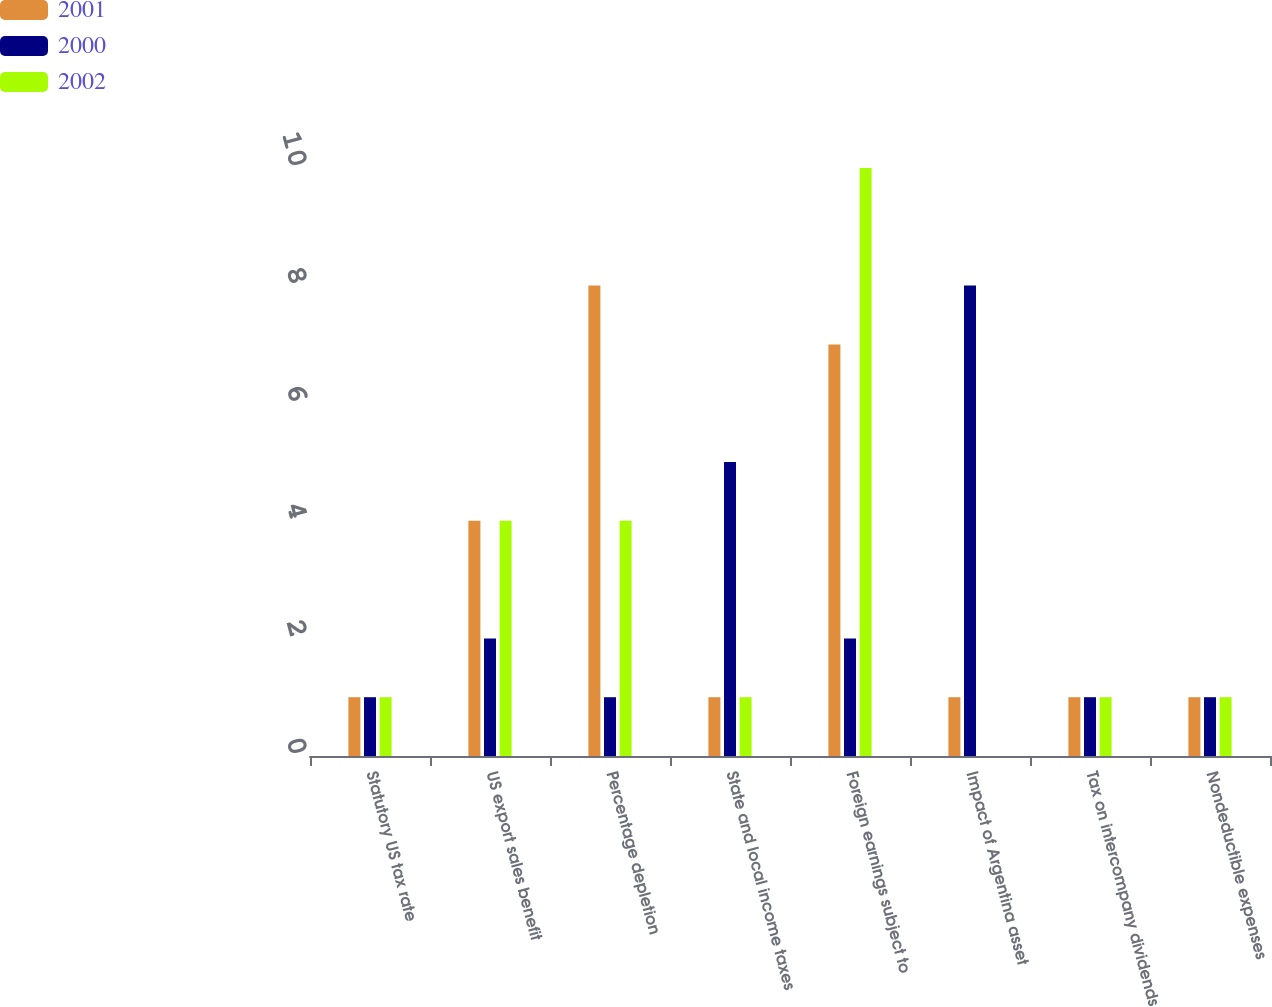Convert chart. <chart><loc_0><loc_0><loc_500><loc_500><stacked_bar_chart><ecel><fcel>Statutory US tax rate<fcel>US export sales benefit<fcel>Percentage depletion<fcel>State and local income taxes<fcel>Foreign earnings subject to<fcel>Impact of Argentina asset<fcel>Tax on intercompany dividends<fcel>Nondeductible expenses<nl><fcel>2001<fcel>1<fcel>4<fcel>8<fcel>1<fcel>7<fcel>1<fcel>1<fcel>1<nl><fcel>2000<fcel>1<fcel>2<fcel>1<fcel>5<fcel>2<fcel>8<fcel>1<fcel>1<nl><fcel>2002<fcel>1<fcel>4<fcel>4<fcel>1<fcel>10<fcel>0<fcel>1<fcel>1<nl></chart> 